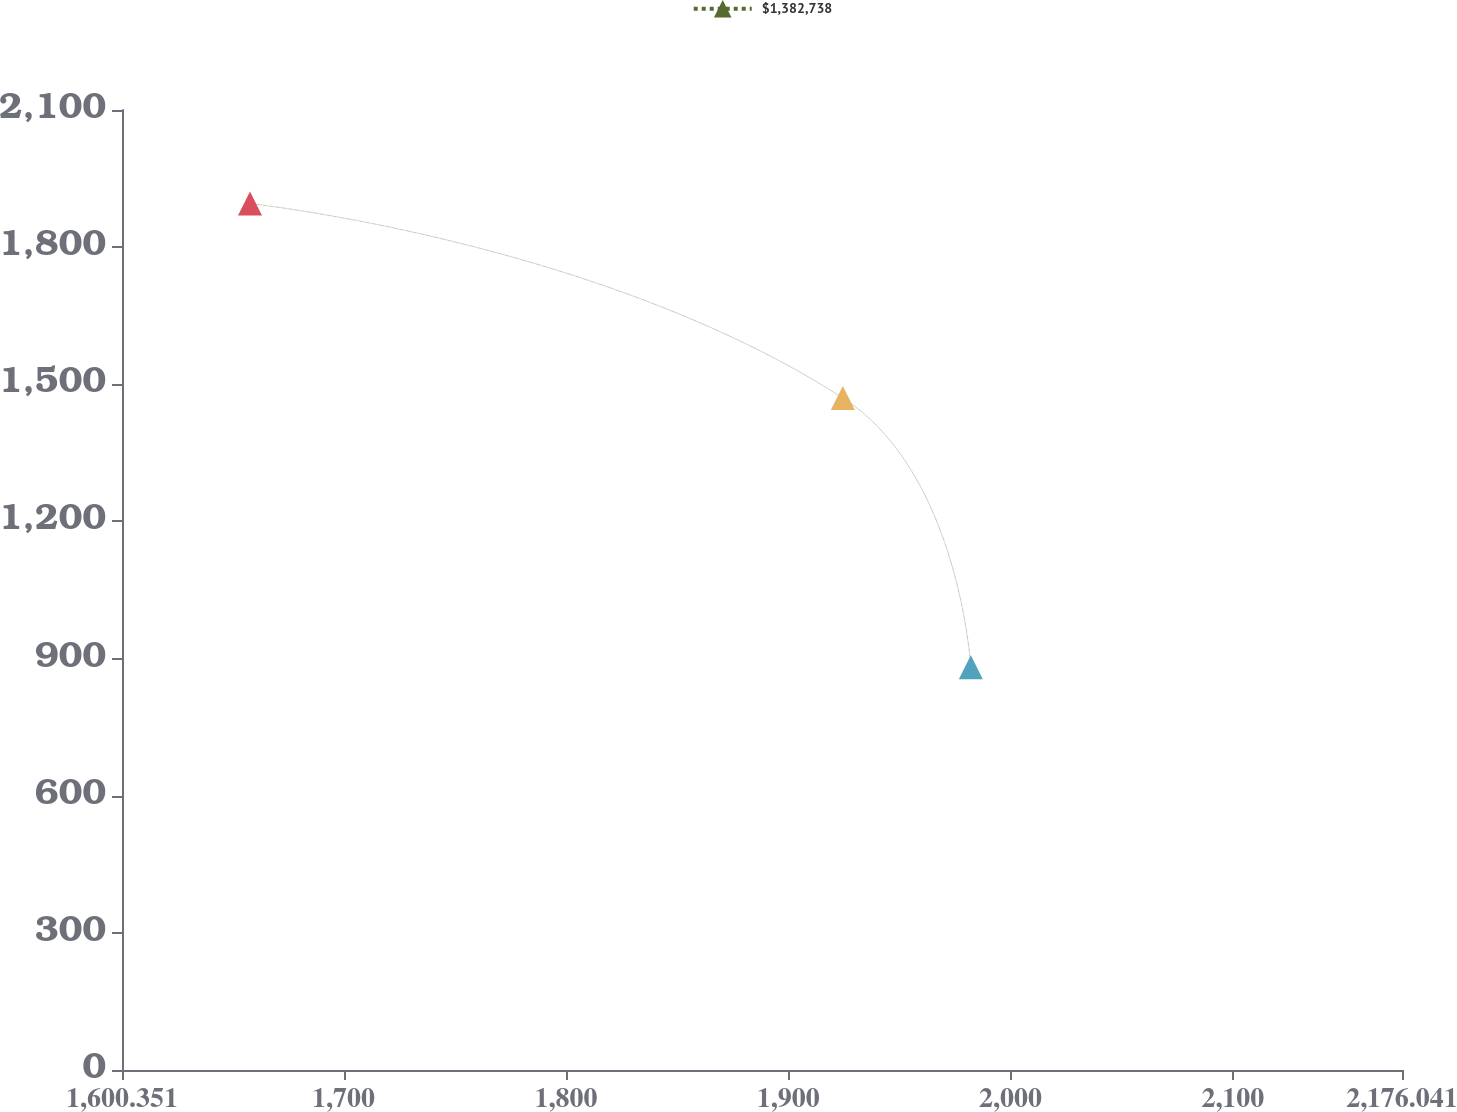Convert chart. <chart><loc_0><loc_0><loc_500><loc_500><line_chart><ecel><fcel>$1,382,738<nl><fcel>1657.92<fcel>1895.24<nl><fcel>1924.55<fcel>1470.14<nl><fcel>1982.12<fcel>880.85<nl><fcel>2233.61<fcel>982.29<nl></chart> 